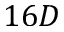Convert formula to latex. <formula><loc_0><loc_0><loc_500><loc_500>1 6 D</formula> 